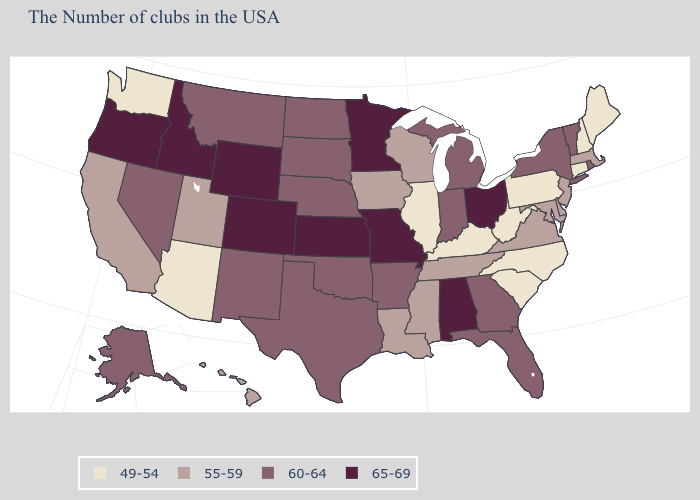Name the states that have a value in the range 49-54?
Concise answer only. Maine, New Hampshire, Connecticut, Pennsylvania, North Carolina, South Carolina, West Virginia, Kentucky, Illinois, Arizona, Washington. Name the states that have a value in the range 55-59?
Give a very brief answer. Massachusetts, New Jersey, Delaware, Maryland, Virginia, Tennessee, Wisconsin, Mississippi, Louisiana, Iowa, Utah, California, Hawaii. Among the states that border Delaware , does Pennsylvania have the lowest value?
Give a very brief answer. Yes. Is the legend a continuous bar?
Be succinct. No. Does Washington have the lowest value in the USA?
Short answer required. Yes. Name the states that have a value in the range 60-64?
Quick response, please. Rhode Island, Vermont, New York, Florida, Georgia, Michigan, Indiana, Arkansas, Nebraska, Oklahoma, Texas, South Dakota, North Dakota, New Mexico, Montana, Nevada, Alaska. Among the states that border Texas , does Louisiana have the highest value?
Short answer required. No. Does New York have the same value as Connecticut?
Short answer required. No. Does North Dakota have a higher value than Oklahoma?
Concise answer only. No. What is the highest value in the MidWest ?
Keep it brief. 65-69. Name the states that have a value in the range 55-59?
Write a very short answer. Massachusetts, New Jersey, Delaware, Maryland, Virginia, Tennessee, Wisconsin, Mississippi, Louisiana, Iowa, Utah, California, Hawaii. What is the value of Delaware?
Answer briefly. 55-59. Name the states that have a value in the range 60-64?
Quick response, please. Rhode Island, Vermont, New York, Florida, Georgia, Michigan, Indiana, Arkansas, Nebraska, Oklahoma, Texas, South Dakota, North Dakota, New Mexico, Montana, Nevada, Alaska. Name the states that have a value in the range 60-64?
Be succinct. Rhode Island, Vermont, New York, Florida, Georgia, Michigan, Indiana, Arkansas, Nebraska, Oklahoma, Texas, South Dakota, North Dakota, New Mexico, Montana, Nevada, Alaska. 